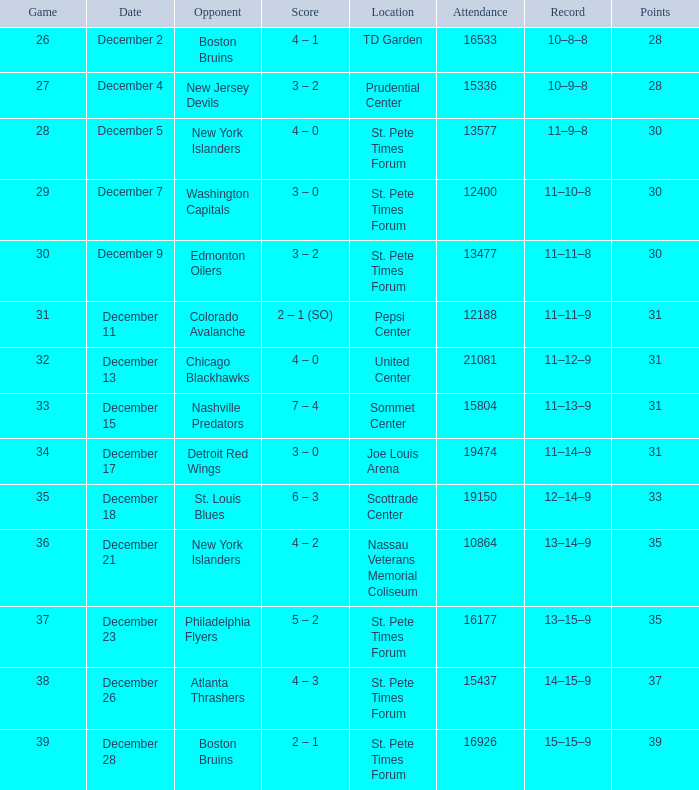What was the largest attended game? 21081.0. 